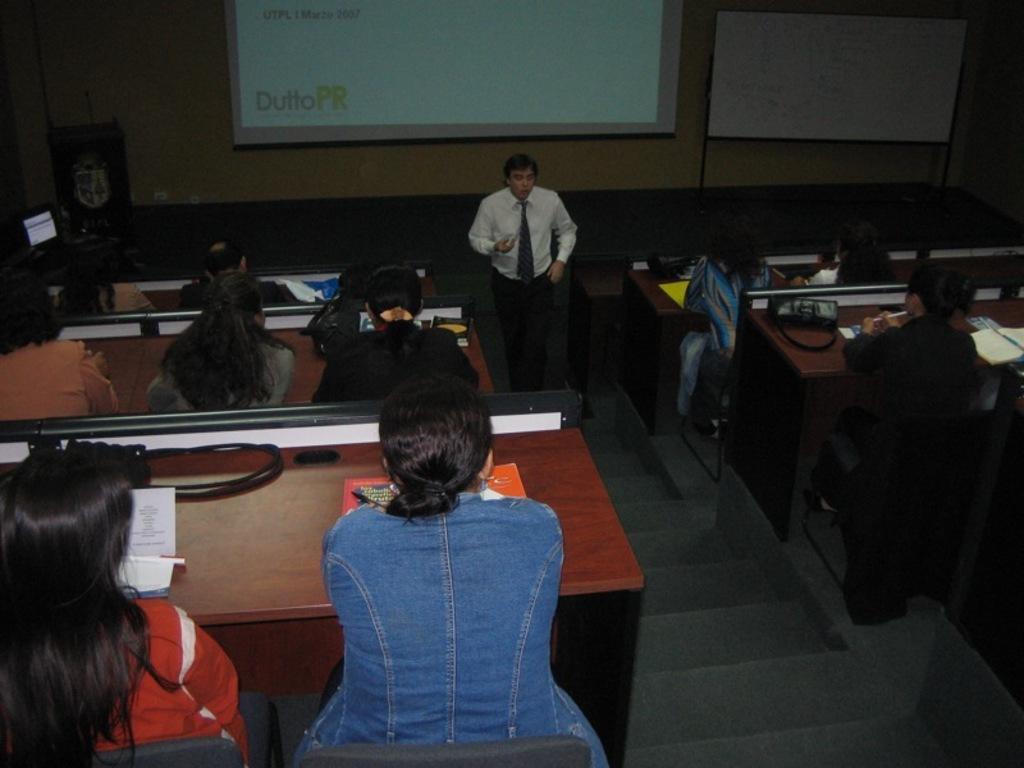How would you summarize this image in a sentence or two? In this image there are group of people who are sitting on the right side and left side and in the center there is one man who is standing and on the background there is a screen and on the right side there is one board and on the tables there are papers and pens are there. 